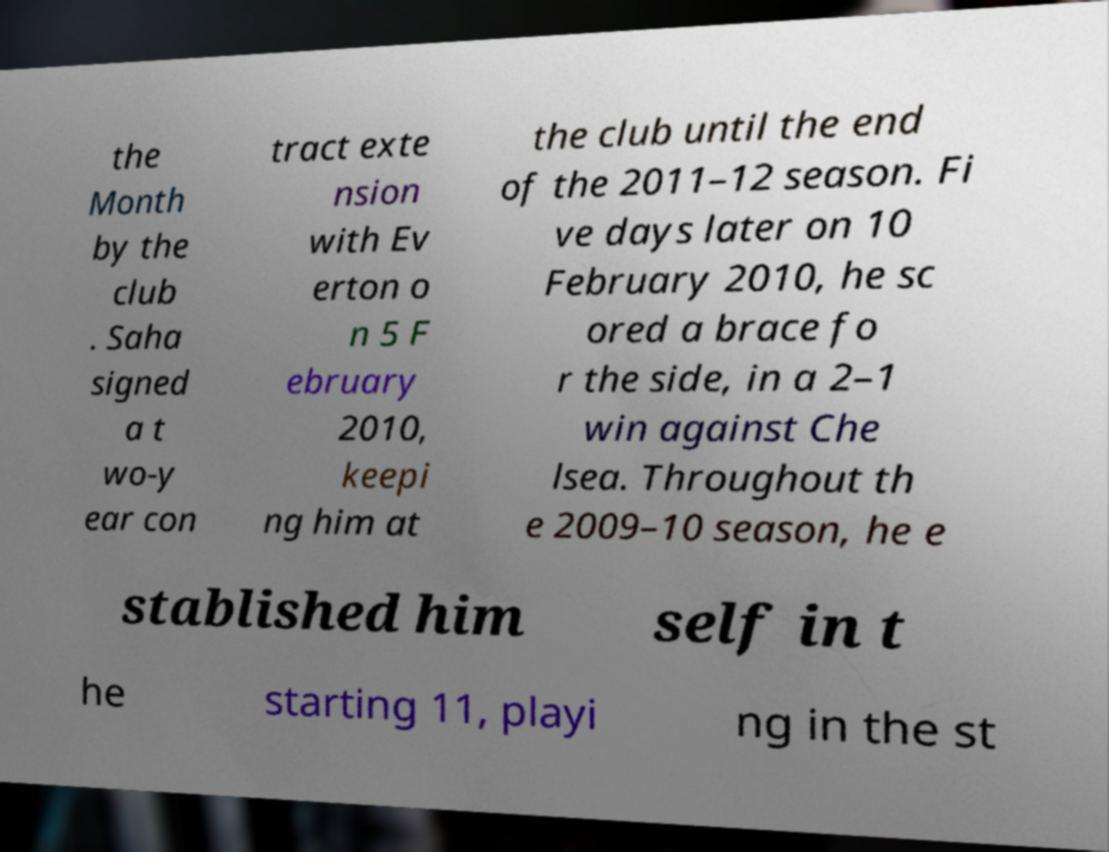Please read and relay the text visible in this image. What does it say? the Month by the club . Saha signed a t wo-y ear con tract exte nsion with Ev erton o n 5 F ebruary 2010, keepi ng him at the club until the end of the 2011–12 season. Fi ve days later on 10 February 2010, he sc ored a brace fo r the side, in a 2–1 win against Che lsea. Throughout th e 2009–10 season, he e stablished him self in t he starting 11, playi ng in the st 